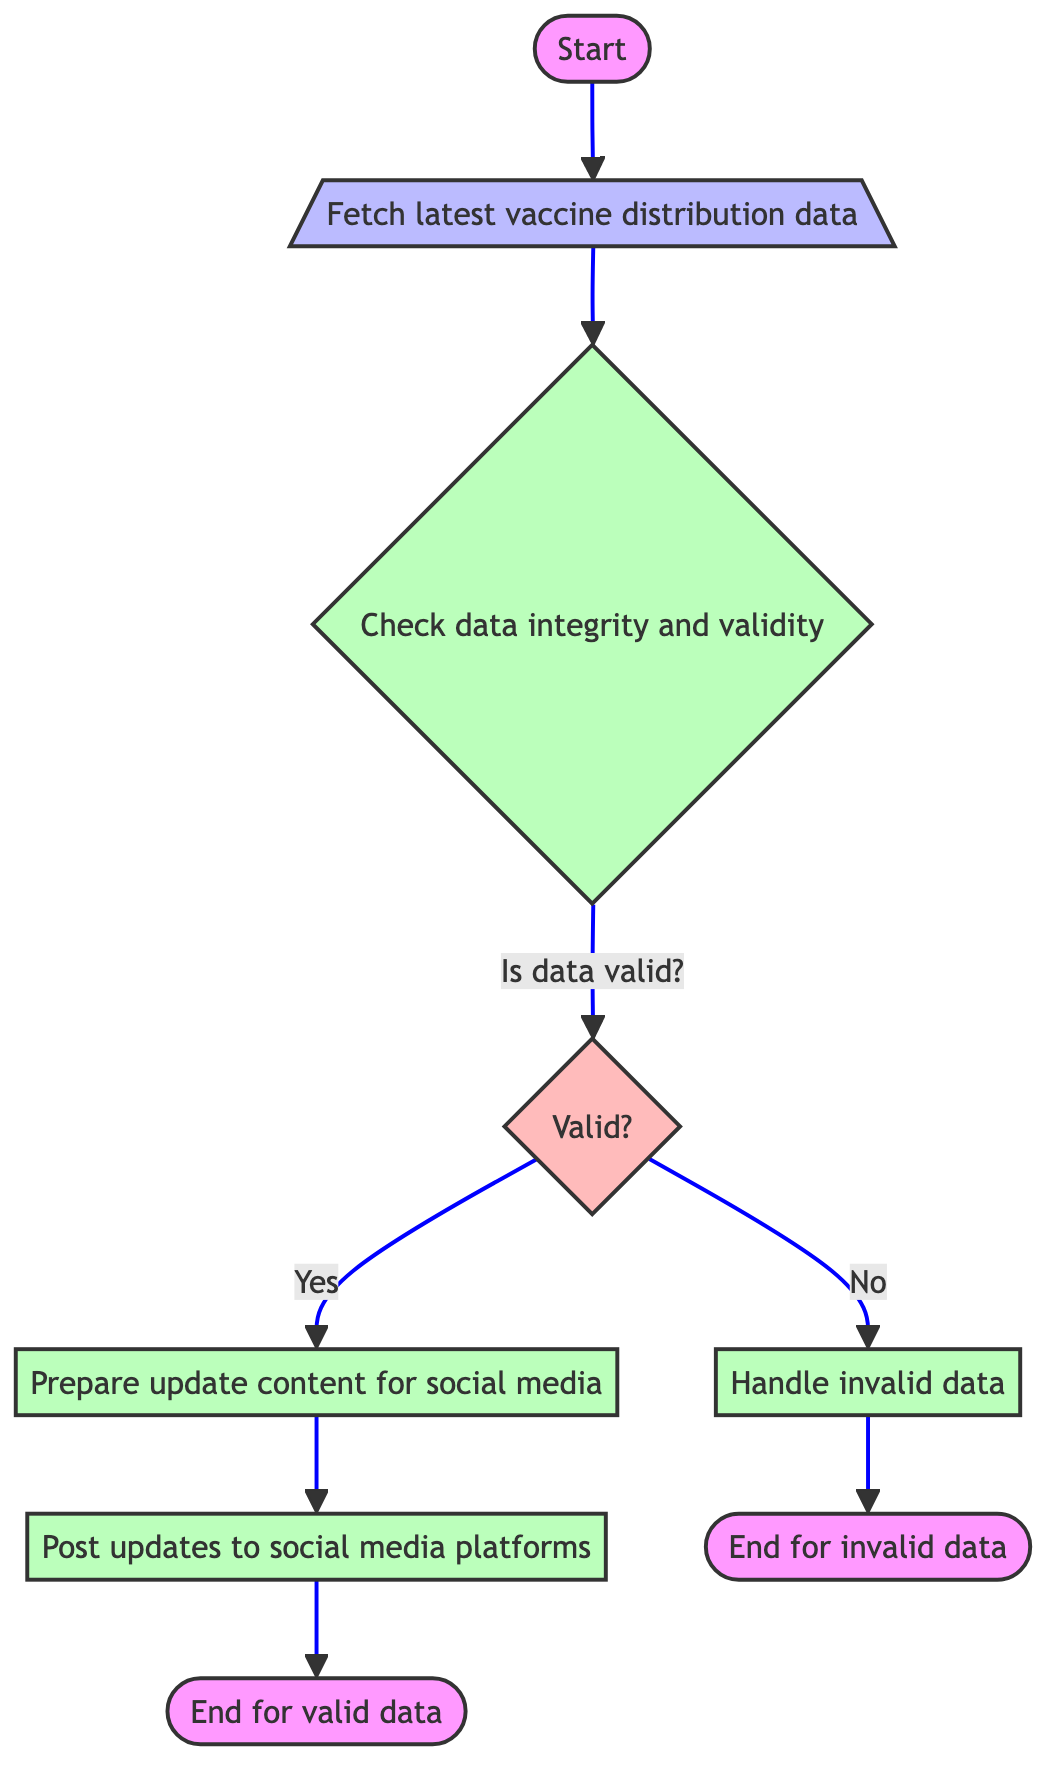What is the first step in the function? The first step in the function is labeled as "Start of the function" in the diagram. It serves as the entry point for the entire process.
Answer: Start of the function How many decision points are there in the flowchart? The flowchart contains one decision point labeled "Is data valid?". This is where the process checks the validity of the data fetched.
Answer: One What action is taken if the data is valid? If the data is valid, the next action taken is to "Prepare update content for social media." This is indicated as the process that follows the decision for valid data.
Answer: Prepare update content for social media What happens after the updates are posted to social media? After the updates are posted to social media platforms, the function concludes with "End of the function for valid data," which signifies the completion of the process for valid updates.
Answer: End of the function for valid data What function is used to fetch the latest vaccine distribution data? The function used to fetch the latest vaccine distribution data is called "fetch_latest_data()". It is the first operation performed in the flowchart.
Answer: fetch_latest_data() What should be done if the data is not valid? If the data is not valid, the flowchart indicates that the next step is to "Handle invalid data." This process occurs after the decision point confirming the data's invalidity.
Answer: Handle invalid data What are the three social media platforms mentioned for posting updates? The three social media platforms mentioned for posting updates are Twitter, Facebook, and Instagram, each having a dedicated function for posting content.
Answer: Twitter, Facebook, Instagram What is the last step if the data is invalid? The last step if the data is invalid is "End of the function for invalid data," indicating that the process concludes when handling invalid data.
Answer: End of the function for invalid data 